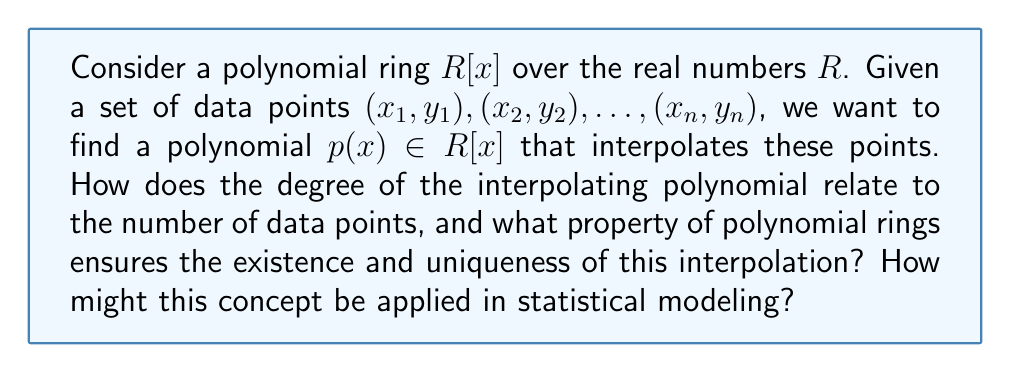Can you solve this math problem? To answer this question, we need to consider several key concepts from polynomial rings and their application to statistical interpolation:

1. Degree of the interpolating polynomial:
   The degree of the interpolating polynomial is directly related to the number of data points. For $n$ distinct data points, we can find a unique polynomial of degree at most $n-1$ that passes through all these points.

2. Existence and uniqueness:
   The existence and uniqueness of the interpolating polynomial are guaranteed by a fundamental property of polynomial rings: the division algorithm. This algorithm states that for any two polynomials $f(x)$ and $g(x)$ in $R[x]$ with $g(x) \neq 0$, there exist unique polynomials $q(x)$ and $r(x)$ such that:

   $$f(x) = g(x)q(x) + r(x)$$

   where the degree of $r(x)$ is less than the degree of $g(x)$.

3. Lagrange interpolation:
   One way to construct the interpolating polynomial is through Lagrange interpolation. The Lagrange interpolating polynomial is given by:

   $$p(x) = \sum_{i=1}^n y_i \prod_{j \neq i} \frac{x - x_j}{x_i - x_j}$$

   This polynomial has degree at most $n-1$ and passes through all $n$ data points.

4. Application to statistical modeling:
   In statistical modeling, polynomial interpolation can be used for curve fitting and prediction. However, it's important to note that while the interpolating polynomial exactly fits the given data points, it may not generalize well to new data due to overfitting, especially for high-degree polynomials.

   Instead, statisticians often use techniques like polynomial regression, which finds a polynomial of a specified degree that minimizes the sum of squared residuals. This approach balances the trade-off between model complexity and goodness of fit.

   The concept of polynomial rings also relates to the study of orthogonal polynomials, which are important in various areas of statistics, including the analysis of time series and the construction of efficient experimental designs.
Answer: The degree of the interpolating polynomial is at most $n-1$ for $n$ distinct data points. The division algorithm in polynomial rings ensures the existence and uniqueness of this interpolation. In statistical modeling, this concept can be applied through techniques like polynomial regression and the study of orthogonal polynomials, balancing model complexity with goodness of fit. 